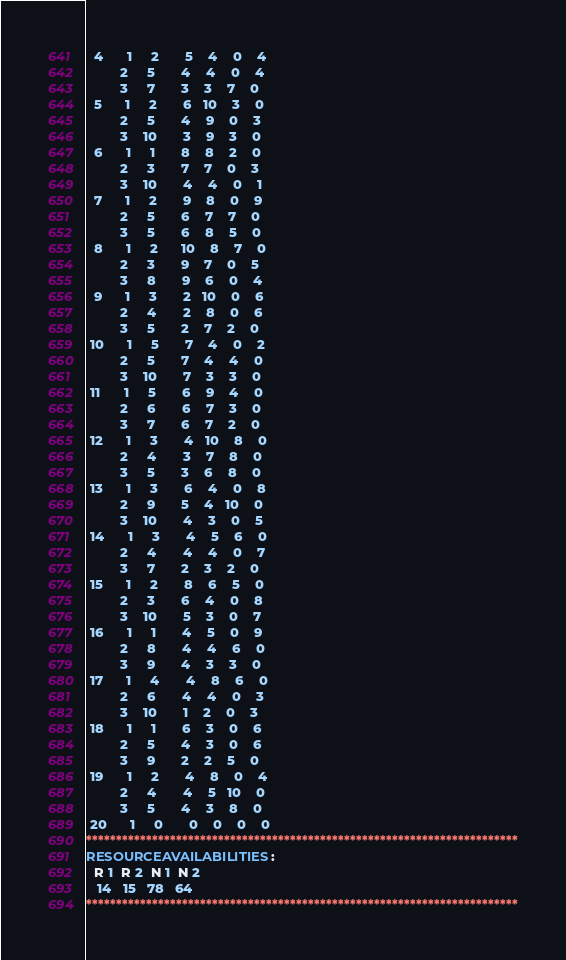<code> <loc_0><loc_0><loc_500><loc_500><_ObjectiveC_>  4      1     2       5    4    0    4
         2     5       4    4    0    4
         3     7       3    3    7    0
  5      1     2       6   10    3    0
         2     5       4    9    0    3
         3    10       3    9    3    0
  6      1     1       8    8    2    0
         2     3       7    7    0    3
         3    10       4    4    0    1
  7      1     2       9    8    0    9
         2     5       6    7    7    0
         3     5       6    8    5    0
  8      1     2      10    8    7    0
         2     3       9    7    0    5
         3     8       9    6    0    4
  9      1     3       2   10    0    6
         2     4       2    8    0    6
         3     5       2    7    2    0
 10      1     5       7    4    0    2
         2     5       7    4    4    0
         3    10       7    3    3    0
 11      1     5       6    9    4    0
         2     6       6    7    3    0
         3     7       6    7    2    0
 12      1     3       4   10    8    0
         2     4       3    7    8    0
         3     5       3    6    8    0
 13      1     3       6    4    0    8
         2     9       5    4   10    0
         3    10       4    3    0    5
 14      1     3       4    5    6    0
         2     4       4    4    0    7
         3     7       2    3    2    0
 15      1     2       8    6    5    0
         2     3       6    4    0    8
         3    10       5    3    0    7
 16      1     1       4    5    0    9
         2     8       4    4    6    0
         3     9       4    3    3    0
 17      1     4       4    8    6    0
         2     6       4    4    0    3
         3    10       1    2    0    3
 18      1     1       6    3    0    6
         2     5       4    3    0    6
         3     9       2    2    5    0
 19      1     2       4    8    0    4
         2     4       4    5   10    0
         3     5       4    3    8    0
 20      1     0       0    0    0    0
************************************************************************
RESOURCEAVAILABILITIES:
  R 1  R 2  N 1  N 2
   14   15   78   64
************************************************************************
</code> 